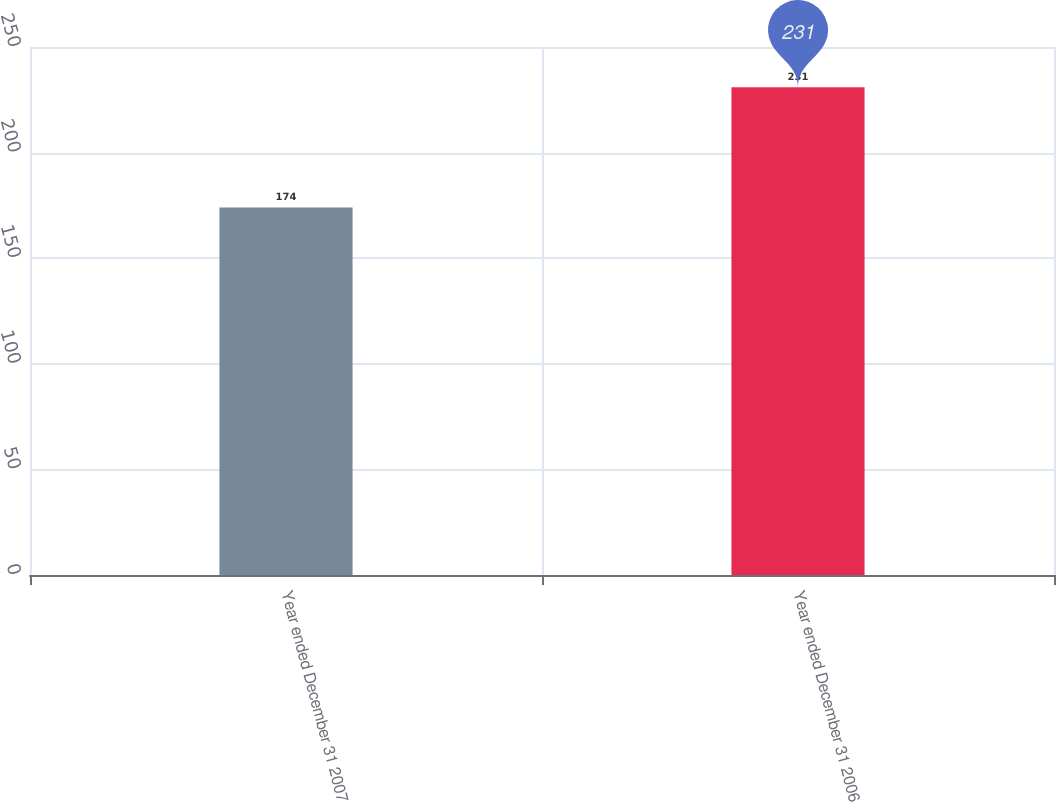Convert chart. <chart><loc_0><loc_0><loc_500><loc_500><bar_chart><fcel>Year ended December 31 2007<fcel>Year ended December 31 2006<nl><fcel>174<fcel>231<nl></chart> 